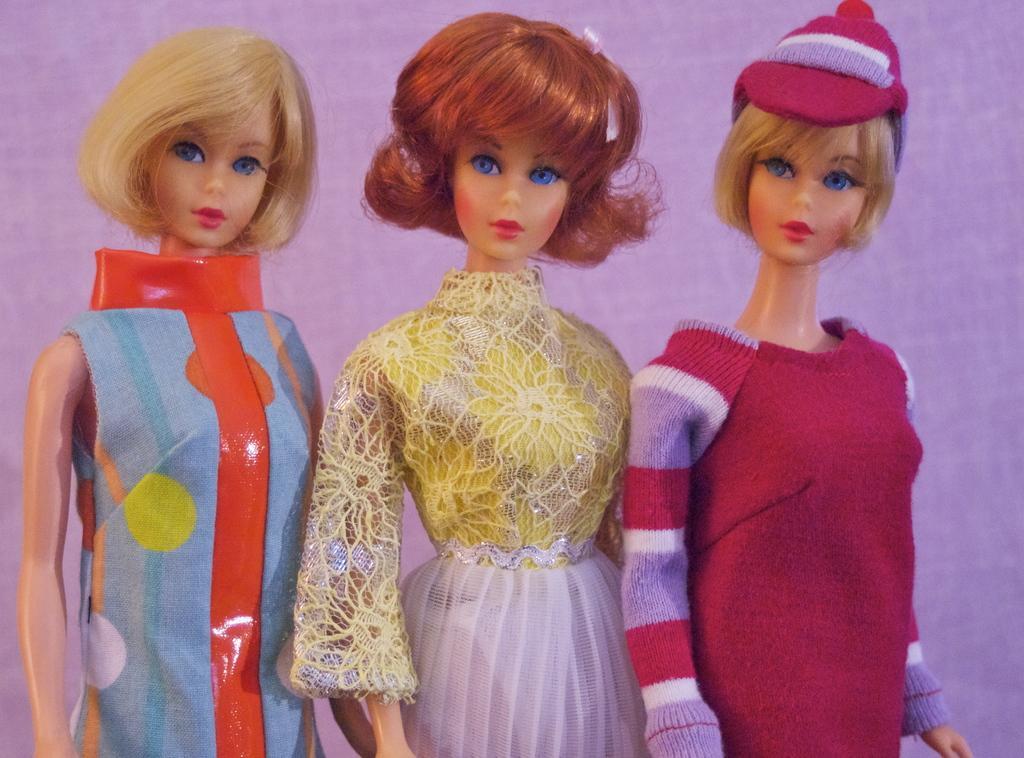Could you give a brief overview of what you see in this image? This image consists of three Barbie dolls. They are wearing different dresses. 